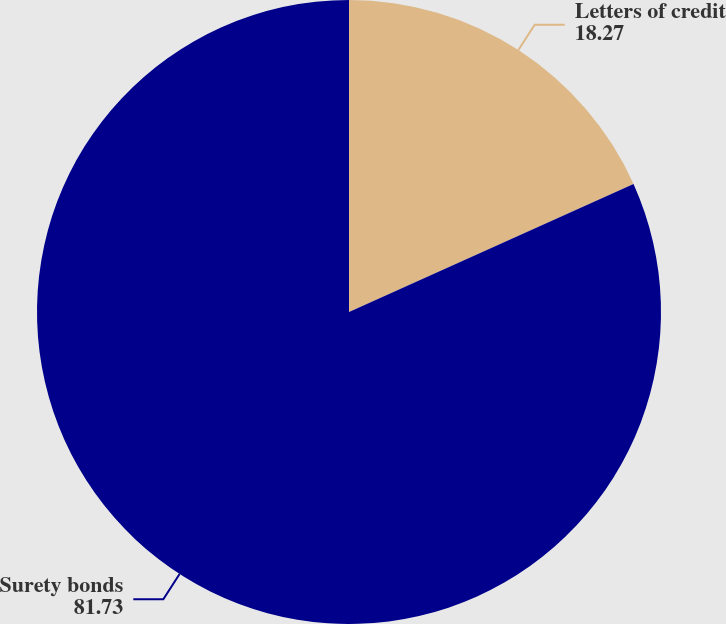<chart> <loc_0><loc_0><loc_500><loc_500><pie_chart><fcel>Letters of credit<fcel>Surety bonds<nl><fcel>18.27%<fcel>81.73%<nl></chart> 